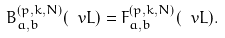<formula> <loc_0><loc_0><loc_500><loc_500>B _ { a , b } ^ { ( p , k , N ) } ( \ v L ) = F _ { a , b } ^ { ( p , k , N ) } ( \ v L ) .</formula> 